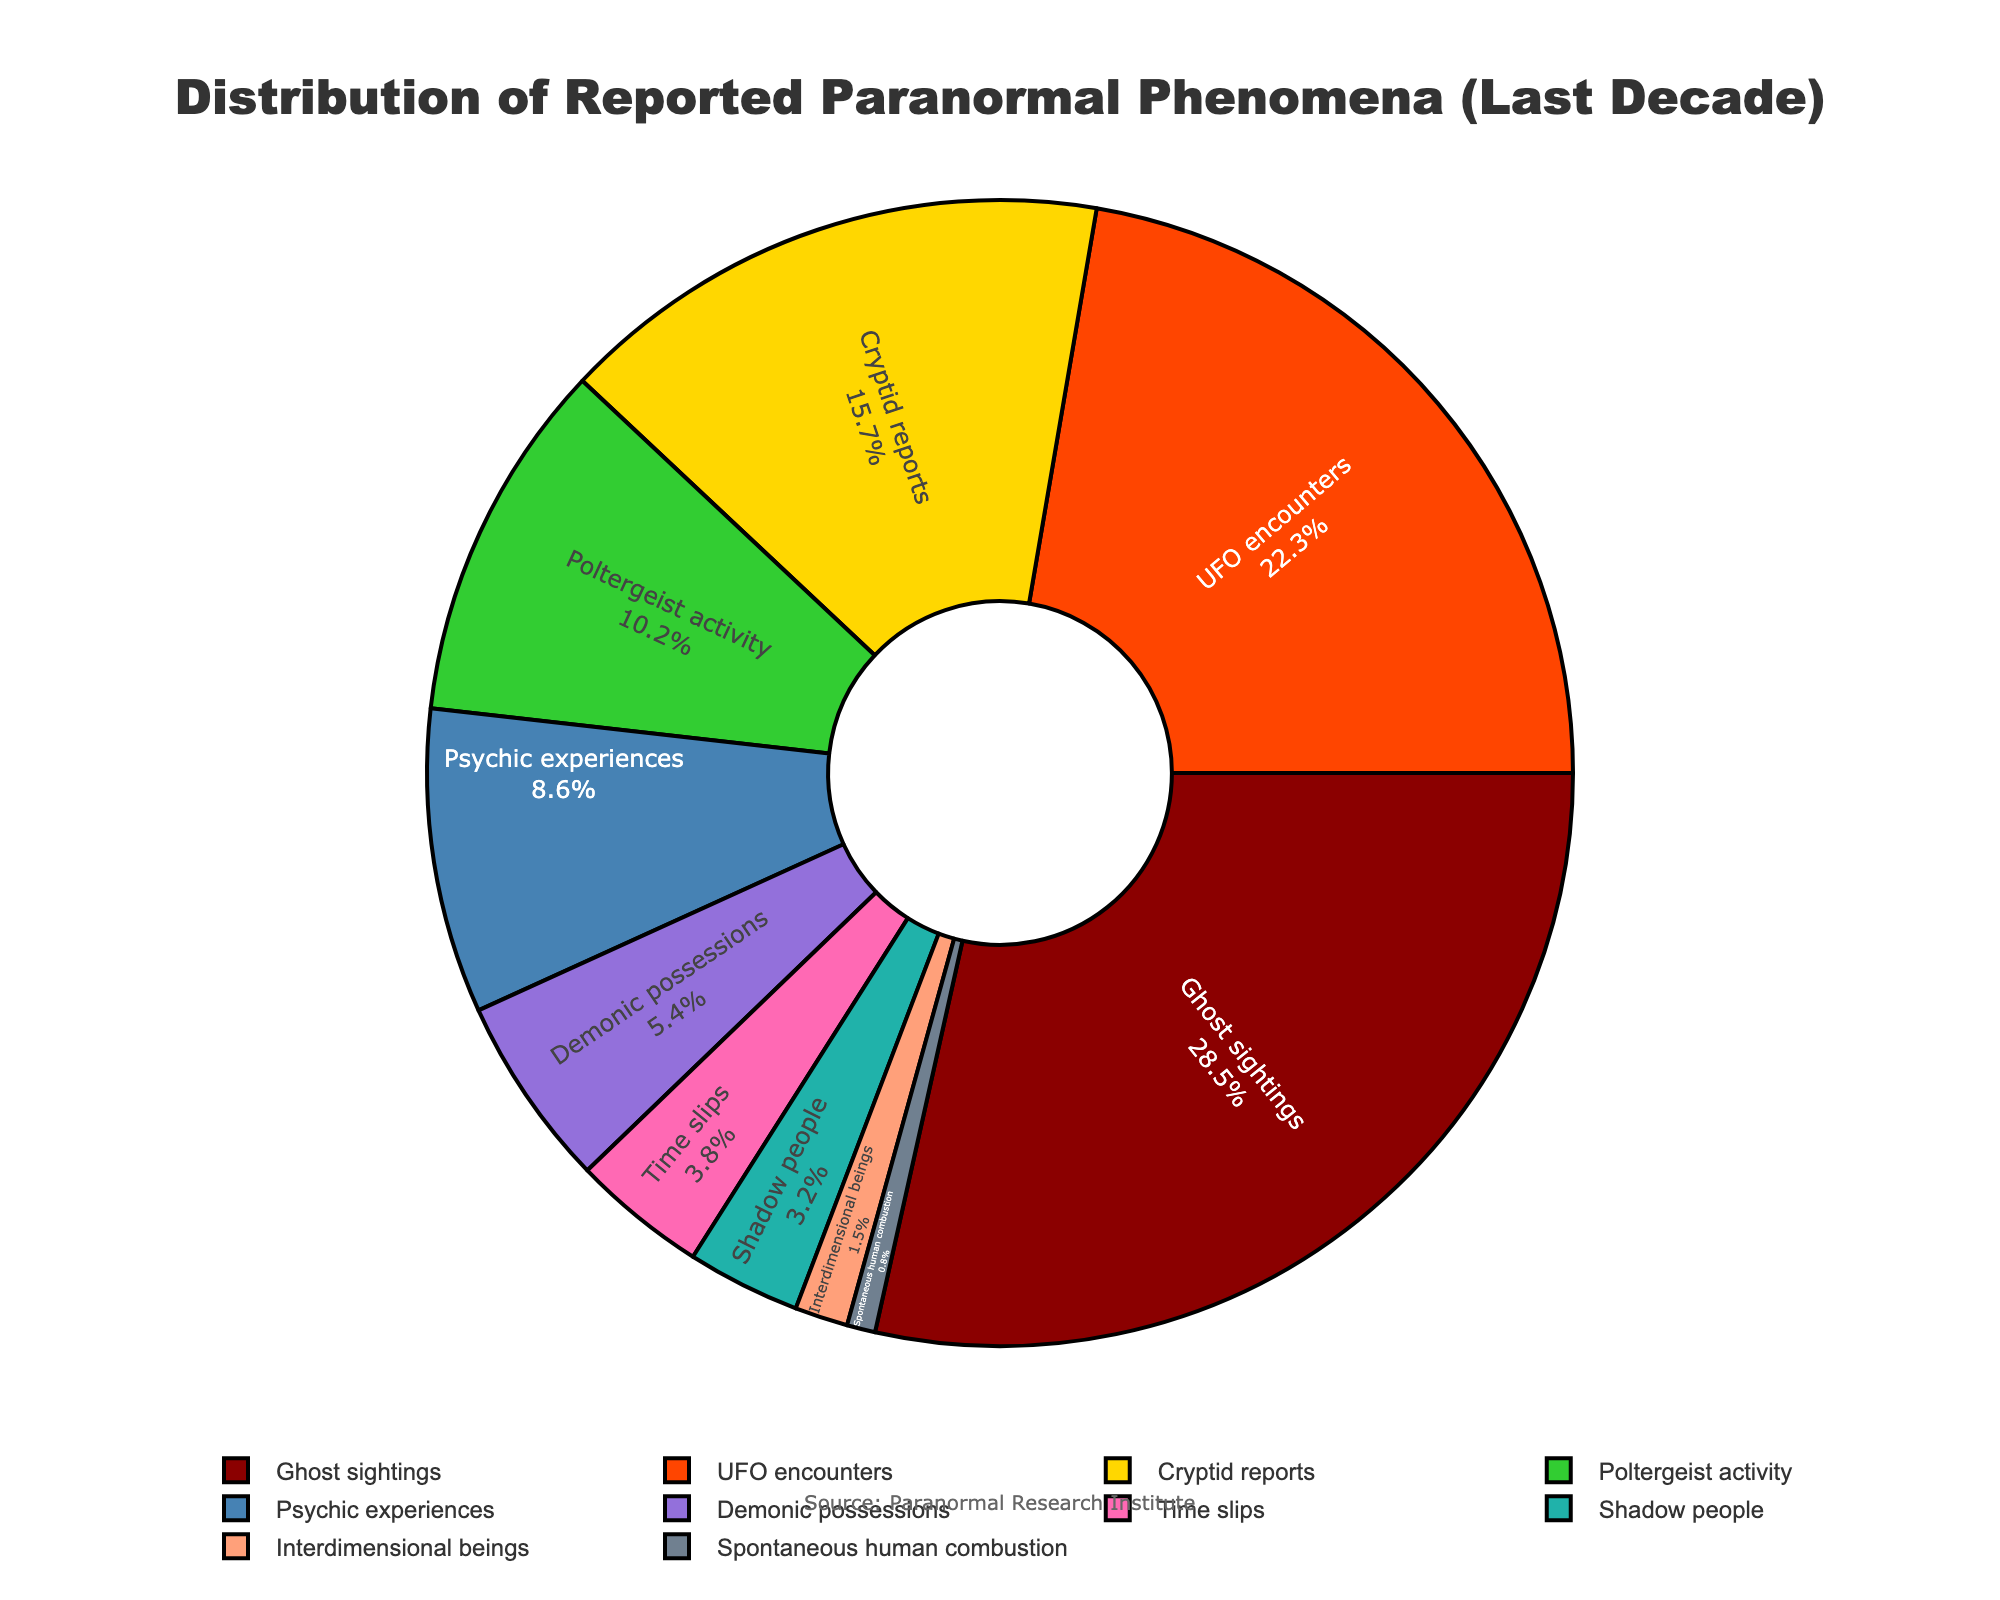What's the most reported type of paranormal phenomenon? The largest segment in the pie chart represents Ghost sightings, which is the most reported type.
Answer: Ghost sightings Which type of phenomenon has a higher percentage: UFO encounters or Cryptid reports? From the pie chart, UFO encounters have a larger segment than Cryptid reports. The respective percentages are 22.3% for UFO encounters and 15.7% for Cryptid reports.
Answer: UFO encounters How much more frequent are Ghost sightings compared to Demonic possessions? First, check the percentages for Ghost sightings and Demonic possessions. The difference is calculated as 28.5% - 5.4% = 23.1%.
Answer: 23.1% What is the combined percentage of Poltergeist activity and Psychic experiences? Sum the percentages of Poltergeist activity (10.2%) and Psychic experiences (8.6%). The total is 10.2% + 8.6% = 18.8%.
Answer: 18.8% What proportion of the reported phenomena is represented by the smallest category? The smallest segment in the pie chart represents Spontaneous human combustion, which accounts for 0.8% of the total.
Answer: 0.8% Which two types of phenomena have the closest percentages? Compare the percentages of the different phenomena. Shadow people (3.2%) and Time slips (3.8%) have the closest percentages, with a difference of only 0.6%.
Answer: Shadow people and Time slips What percentage of phenomena reports fall under Shadow people, Interdimensional beings, and Spontaneous human combustion combined? Add the percentages: Shadow people (3.2%), Interdimensional beings (1.5%), and Spontaneous human combustion (0.8%). The total is 3.2% + 1.5% + 0.8% = 5.5%.
Answer: 5.5% Is the visual representation of UFO encounters segment larger or smaller than that of Poltergeist activity? By comparing the segment sizes visually, the UFO encounters segment is larger than the Poltergeist activity segment in the pie chart.
Answer: Larger What is the percentage difference between Cryptid reports and Time slips? Subtract the percentage of Time slips (3.8%) from Cryptid reports (15.7%). 15.7% - 3.8% = 11.9%.
Answer: 11.9% Which phenomenon type falls below the 10% mark but above 5%? Check the segments that have percentages between 5% and 10%. Psychic experiences (8.6%) and Demonic possessions (5.4%) fit this criterion.
Answer: Psychic experiences and Demonic possessions 